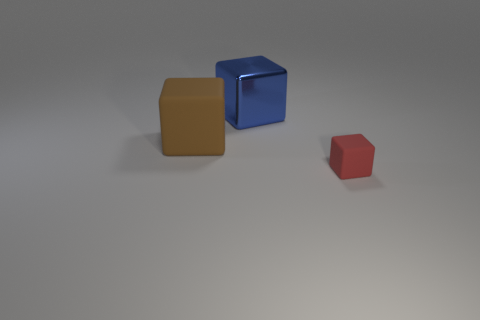What number of gray things are rubber cylinders or tiny matte things?
Offer a terse response. 0. Are there any other things that are made of the same material as the brown cube?
Provide a succinct answer. Yes. Does the block that is in front of the big rubber object have the same material as the brown thing?
Provide a succinct answer. Yes. How many things are either large brown cubes or matte things to the right of the blue thing?
Offer a very short reply. 2. What number of cubes are left of the large thing that is on the right side of the rubber thing behind the red matte thing?
Provide a short and direct response. 1. There is a matte thing that is left of the tiny red cube; is it the same shape as the red thing?
Offer a terse response. Yes. There is a rubber block that is on the right side of the big rubber block; is there a metal block that is in front of it?
Your response must be concise. No. How many brown matte cubes are there?
Ensure brevity in your answer.  1. The object that is both in front of the big blue block and to the right of the brown cube is what color?
Provide a succinct answer. Red. The other red thing that is the same shape as the shiny thing is what size?
Give a very brief answer. Small. 